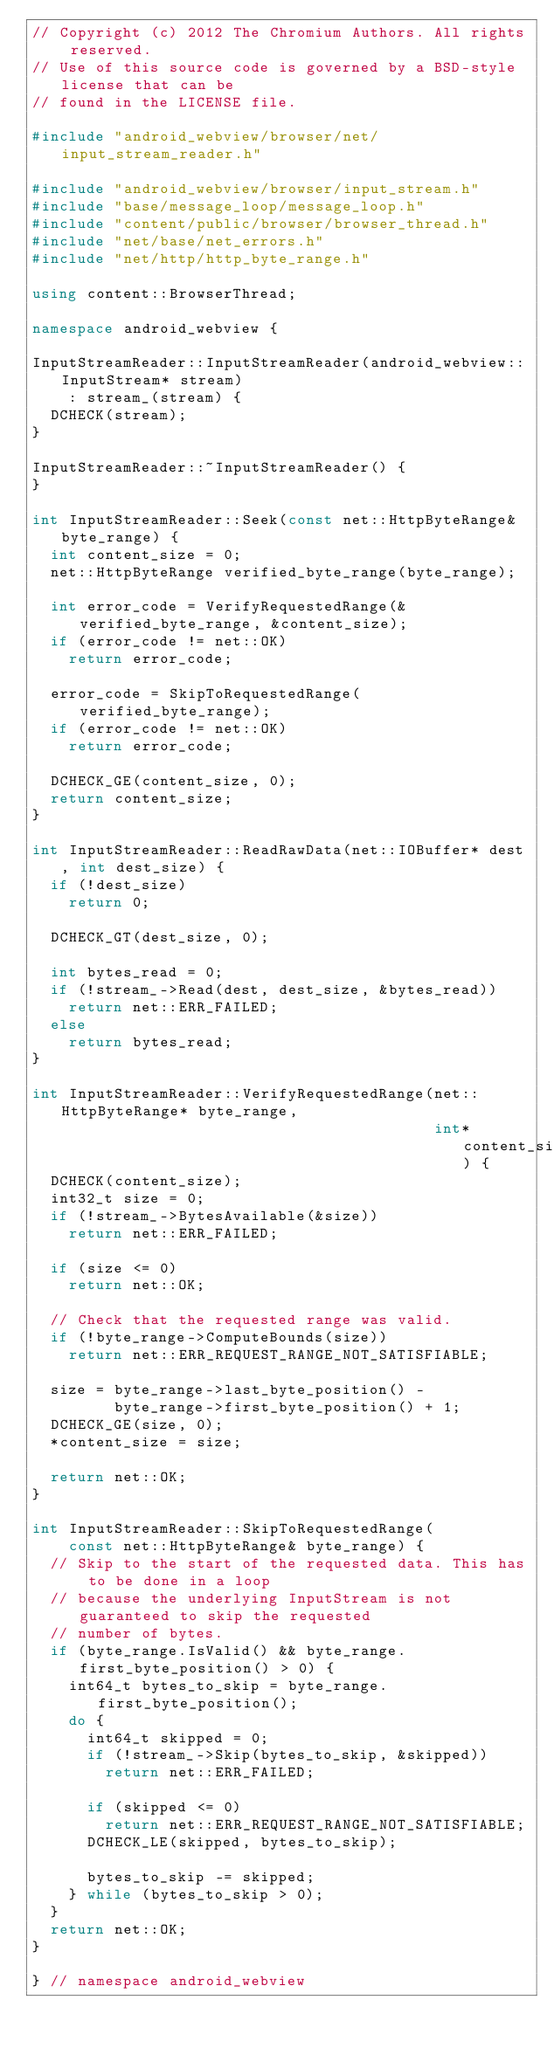<code> <loc_0><loc_0><loc_500><loc_500><_C++_>// Copyright (c) 2012 The Chromium Authors. All rights reserved.
// Use of this source code is governed by a BSD-style license that can be
// found in the LICENSE file.

#include "android_webview/browser/net/input_stream_reader.h"

#include "android_webview/browser/input_stream.h"
#include "base/message_loop/message_loop.h"
#include "content/public/browser/browser_thread.h"
#include "net/base/net_errors.h"
#include "net/http/http_byte_range.h"

using content::BrowserThread;

namespace android_webview {

InputStreamReader::InputStreamReader(android_webview::InputStream* stream)
    : stream_(stream) {
  DCHECK(stream);
}

InputStreamReader::~InputStreamReader() {
}

int InputStreamReader::Seek(const net::HttpByteRange& byte_range) {
  int content_size = 0;
  net::HttpByteRange verified_byte_range(byte_range);

  int error_code = VerifyRequestedRange(&verified_byte_range, &content_size);
  if (error_code != net::OK)
    return error_code;

  error_code = SkipToRequestedRange(verified_byte_range);
  if (error_code != net::OK)
    return error_code;

  DCHECK_GE(content_size, 0);
  return content_size;
}

int InputStreamReader::ReadRawData(net::IOBuffer* dest, int dest_size) {
  if (!dest_size)
    return 0;

  DCHECK_GT(dest_size, 0);

  int bytes_read = 0;
  if (!stream_->Read(dest, dest_size, &bytes_read))
    return net::ERR_FAILED;
  else
    return bytes_read;
}

int InputStreamReader::VerifyRequestedRange(net::HttpByteRange* byte_range,
                                            int* content_size) {
  DCHECK(content_size);
  int32_t size = 0;
  if (!stream_->BytesAvailable(&size))
    return net::ERR_FAILED;

  if (size <= 0)
    return net::OK;

  // Check that the requested range was valid.
  if (!byte_range->ComputeBounds(size))
    return net::ERR_REQUEST_RANGE_NOT_SATISFIABLE;

  size = byte_range->last_byte_position() -
         byte_range->first_byte_position() + 1;
  DCHECK_GE(size, 0);
  *content_size = size;

  return net::OK;
}

int InputStreamReader::SkipToRequestedRange(
    const net::HttpByteRange& byte_range) {
  // Skip to the start of the requested data. This has to be done in a loop
  // because the underlying InputStream is not guaranteed to skip the requested
  // number of bytes.
  if (byte_range.IsValid() && byte_range.first_byte_position() > 0) {
    int64_t bytes_to_skip = byte_range.first_byte_position();
    do {
      int64_t skipped = 0;
      if (!stream_->Skip(bytes_to_skip, &skipped))
        return net::ERR_FAILED;

      if (skipped <= 0)
        return net::ERR_REQUEST_RANGE_NOT_SATISFIABLE;
      DCHECK_LE(skipped, bytes_to_skip);

      bytes_to_skip -= skipped;
    } while (bytes_to_skip > 0);
  }
  return net::OK;
}

} // namespace android_webview
</code> 